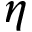Convert formula to latex. <formula><loc_0><loc_0><loc_500><loc_500>\eta</formula> 